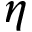Convert formula to latex. <formula><loc_0><loc_0><loc_500><loc_500>\eta</formula> 